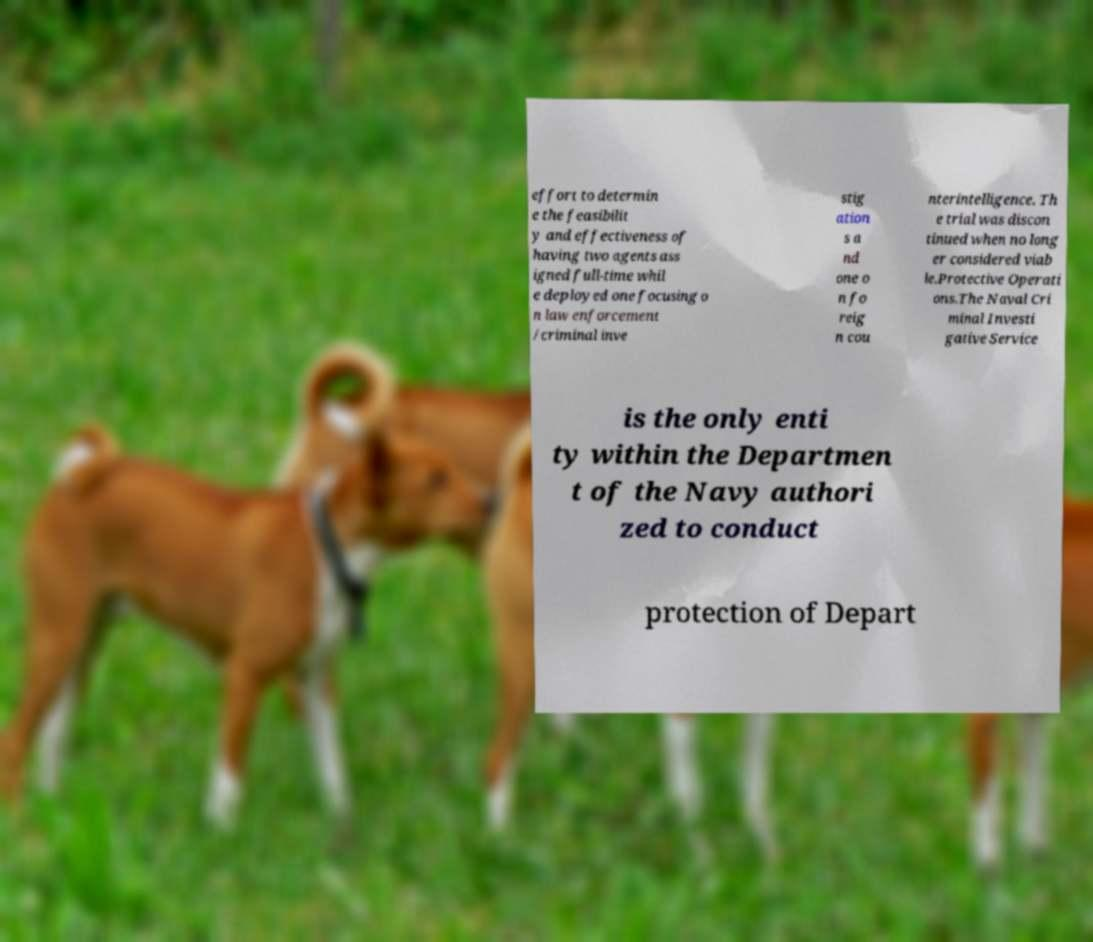Could you assist in decoding the text presented in this image and type it out clearly? effort to determin e the feasibilit y and effectiveness of having two agents ass igned full-time whil e deployed one focusing o n law enforcement /criminal inve stig ation s a nd one o n fo reig n cou nterintelligence. Th e trial was discon tinued when no long er considered viab le.Protective Operati ons.The Naval Cri minal Investi gative Service is the only enti ty within the Departmen t of the Navy authori zed to conduct protection of Depart 